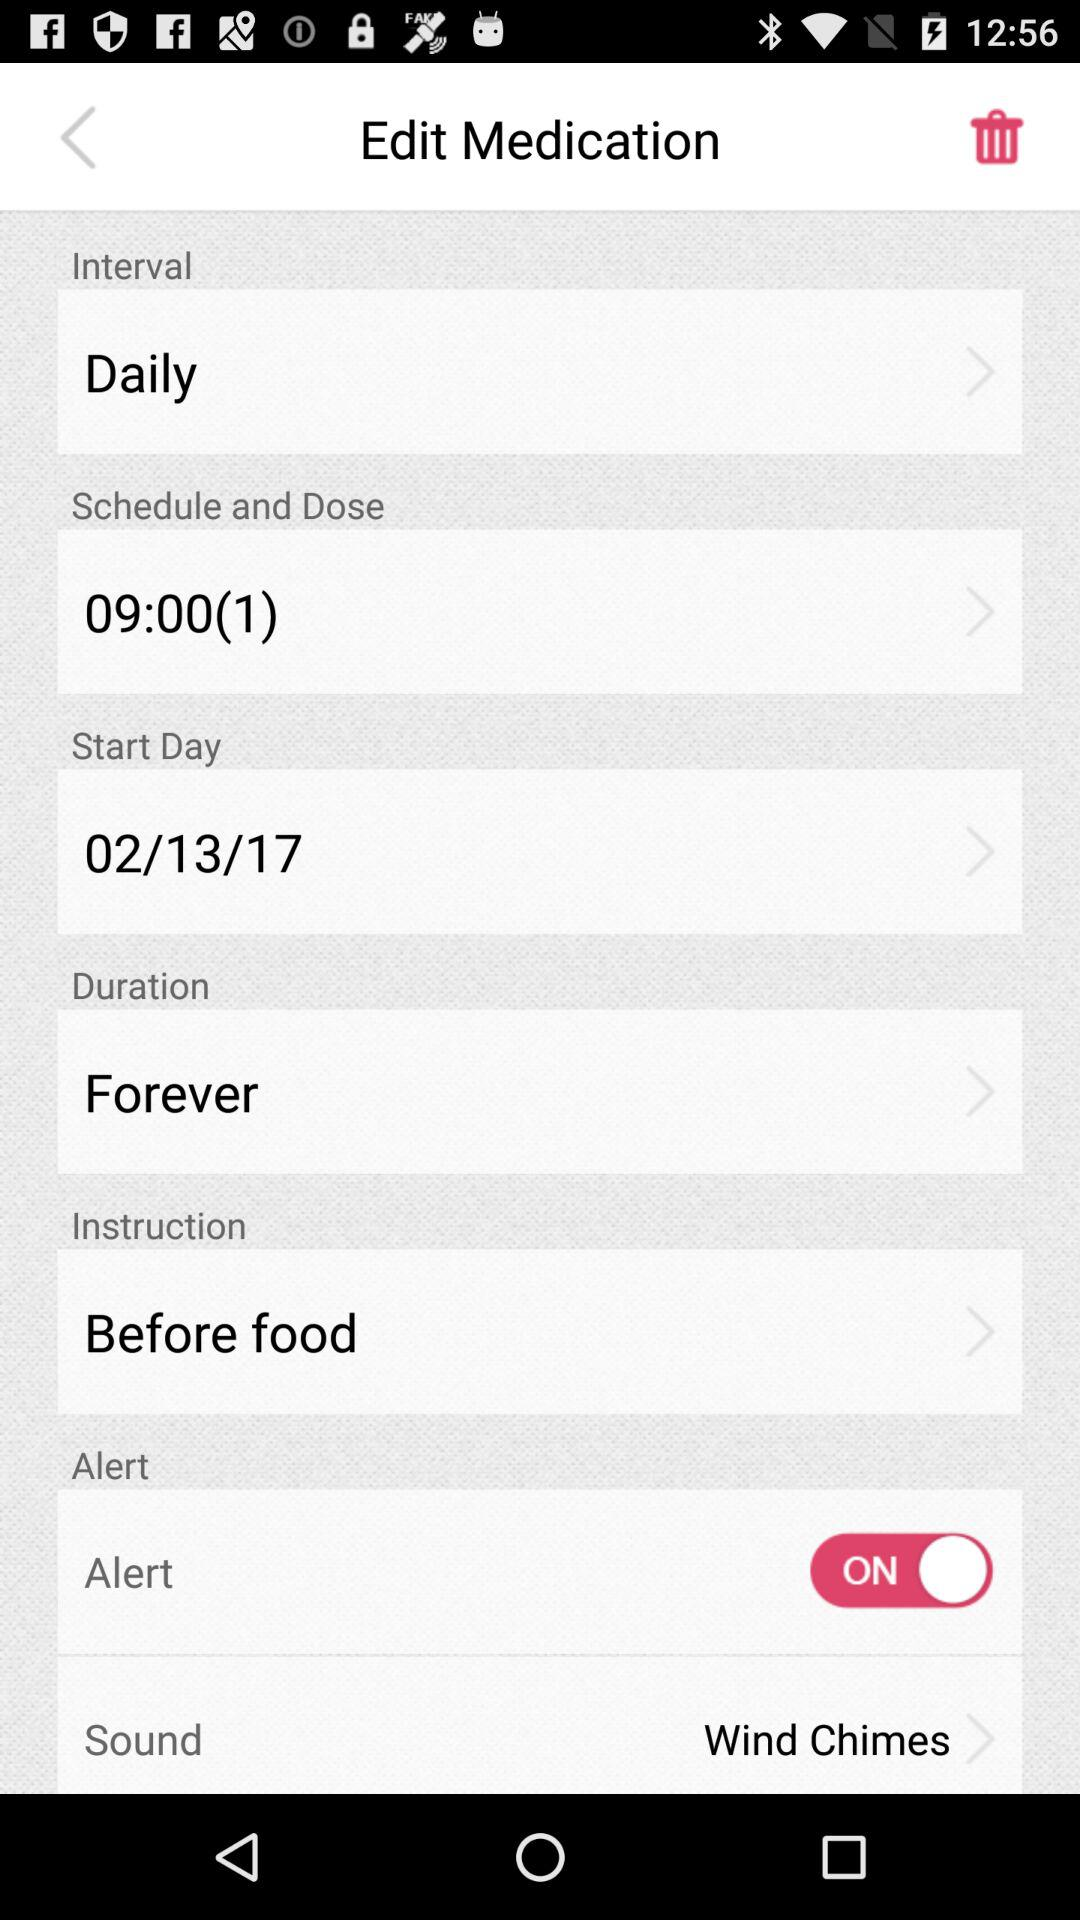What's the given interval of medication? The given interval of medication is "Daily". 